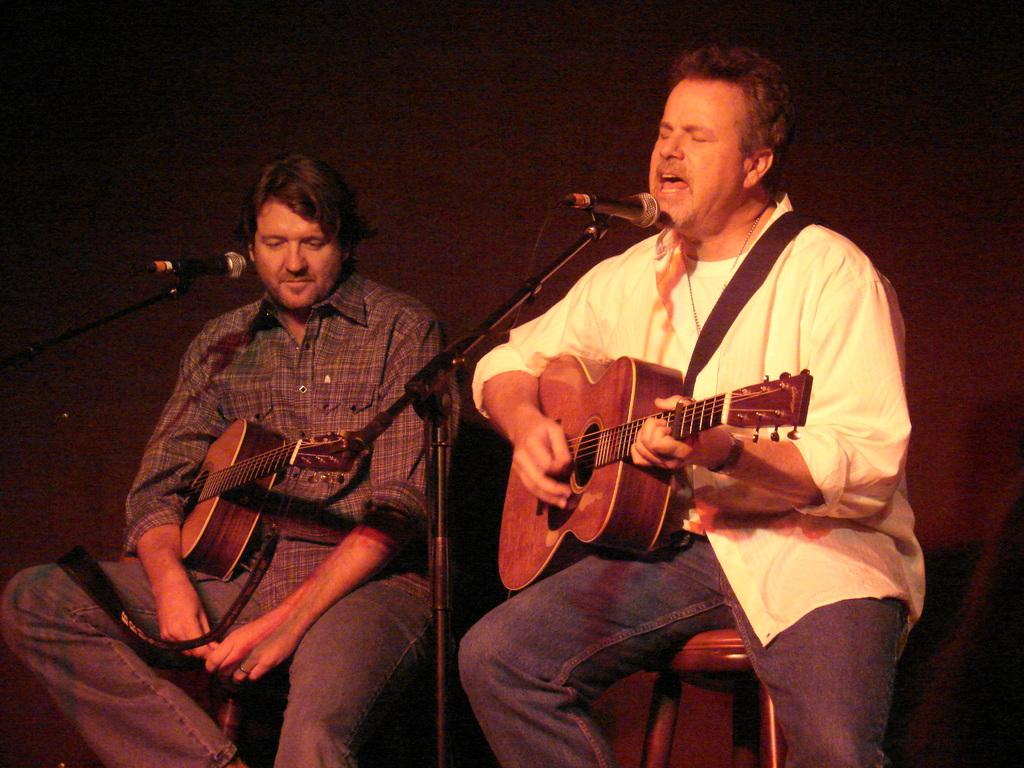How many men are in the image? There are two men in the image. What is the position of the man on the right side? The man on the right side is sitting. What is the man on the right side doing? The man on the right side is playing a guitar and singing. What object is present in the image that is typically used for amplifying sound? There is a microphone in the image. Where is the microphone located in the image? The microphone is in the background of the image. What can be seen in the background of the image? There is a curtain in the background of the image. What type of drug can be seen in the image? There is no drug present in the image. What is the man on the left side using to connect the guitar to the microphone? There is no mention of a guitar being connected to a microphone in the image, nor is there any object present that could be used for such a connection. 